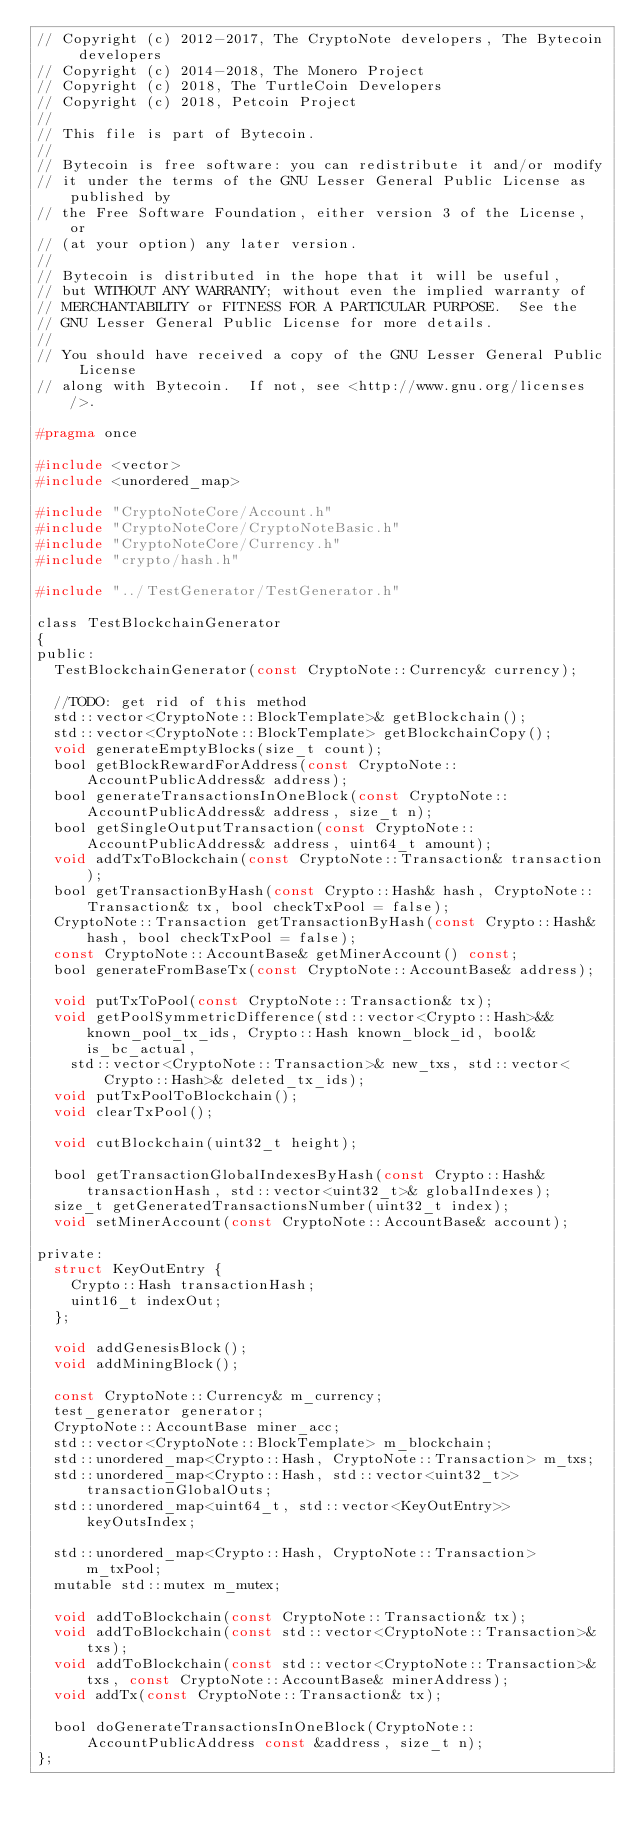<code> <loc_0><loc_0><loc_500><loc_500><_C_>// Copyright (c) 2012-2017, The CryptoNote developers, The Bytecoin developers
// Copyright (c) 2014-2018, The Monero Project
// Copyright (c) 2018, The TurtleCoin Developers
// Copyright (c) 2018, Petcoin Project
//
// This file is part of Bytecoin.
//
// Bytecoin is free software: you can redistribute it and/or modify
// it under the terms of the GNU Lesser General Public License as published by
// the Free Software Foundation, either version 3 of the License, or
// (at your option) any later version.
//
// Bytecoin is distributed in the hope that it will be useful,
// but WITHOUT ANY WARRANTY; without even the implied warranty of
// MERCHANTABILITY or FITNESS FOR A PARTICULAR PURPOSE.  See the
// GNU Lesser General Public License for more details.
//
// You should have received a copy of the GNU Lesser General Public License
// along with Bytecoin.  If not, see <http://www.gnu.org/licenses/>.

#pragma once

#include <vector>
#include <unordered_map>

#include "CryptoNoteCore/Account.h"
#include "CryptoNoteCore/CryptoNoteBasic.h"
#include "CryptoNoteCore/Currency.h"
#include "crypto/hash.h"

#include "../TestGenerator/TestGenerator.h"

class TestBlockchainGenerator
{
public:
  TestBlockchainGenerator(const CryptoNote::Currency& currency);

  //TODO: get rid of this method
  std::vector<CryptoNote::BlockTemplate>& getBlockchain();
  std::vector<CryptoNote::BlockTemplate> getBlockchainCopy();
  void generateEmptyBlocks(size_t count);
  bool getBlockRewardForAddress(const CryptoNote::AccountPublicAddress& address);
  bool generateTransactionsInOneBlock(const CryptoNote::AccountPublicAddress& address, size_t n);
  bool getSingleOutputTransaction(const CryptoNote::AccountPublicAddress& address, uint64_t amount);
  void addTxToBlockchain(const CryptoNote::Transaction& transaction);
  bool getTransactionByHash(const Crypto::Hash& hash, CryptoNote::Transaction& tx, bool checkTxPool = false);
  CryptoNote::Transaction getTransactionByHash(const Crypto::Hash& hash, bool checkTxPool = false);
  const CryptoNote::AccountBase& getMinerAccount() const;
  bool generateFromBaseTx(const CryptoNote::AccountBase& address);

  void putTxToPool(const CryptoNote::Transaction& tx);
  void getPoolSymmetricDifference(std::vector<Crypto::Hash>&& known_pool_tx_ids, Crypto::Hash known_block_id, bool& is_bc_actual,
    std::vector<CryptoNote::Transaction>& new_txs, std::vector<Crypto::Hash>& deleted_tx_ids);
  void putTxPoolToBlockchain();
  void clearTxPool();

  void cutBlockchain(uint32_t height);

  bool getTransactionGlobalIndexesByHash(const Crypto::Hash& transactionHash, std::vector<uint32_t>& globalIndexes);
  size_t getGeneratedTransactionsNumber(uint32_t index);
  void setMinerAccount(const CryptoNote::AccountBase& account);

private:
  struct KeyOutEntry {
    Crypto::Hash transactionHash;
    uint16_t indexOut;
  };
  
  void addGenesisBlock();
  void addMiningBlock();

  const CryptoNote::Currency& m_currency;
  test_generator generator;
  CryptoNote::AccountBase miner_acc;
  std::vector<CryptoNote::BlockTemplate> m_blockchain;
  std::unordered_map<Crypto::Hash, CryptoNote::Transaction> m_txs;
  std::unordered_map<Crypto::Hash, std::vector<uint32_t>> transactionGlobalOuts;
  std::unordered_map<uint64_t, std::vector<KeyOutEntry>> keyOutsIndex;

  std::unordered_map<Crypto::Hash, CryptoNote::Transaction> m_txPool;
  mutable std::mutex m_mutex;

  void addToBlockchain(const CryptoNote::Transaction& tx);
  void addToBlockchain(const std::vector<CryptoNote::Transaction>& txs);
  void addToBlockchain(const std::vector<CryptoNote::Transaction>& txs, const CryptoNote::AccountBase& minerAddress);
  void addTx(const CryptoNote::Transaction& tx);

  bool doGenerateTransactionsInOneBlock(CryptoNote::AccountPublicAddress const &address, size_t n);
};
</code> 